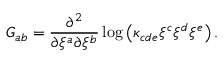<formula> <loc_0><loc_0><loc_500><loc_500>G _ { a b } = \frac { \partial ^ { 2 } } { \partial \xi ^ { a } \partial \xi ^ { b } } \log \left ( \kappa _ { c d e } \xi ^ { c } \xi ^ { d } \xi ^ { e } \right ) .</formula> 